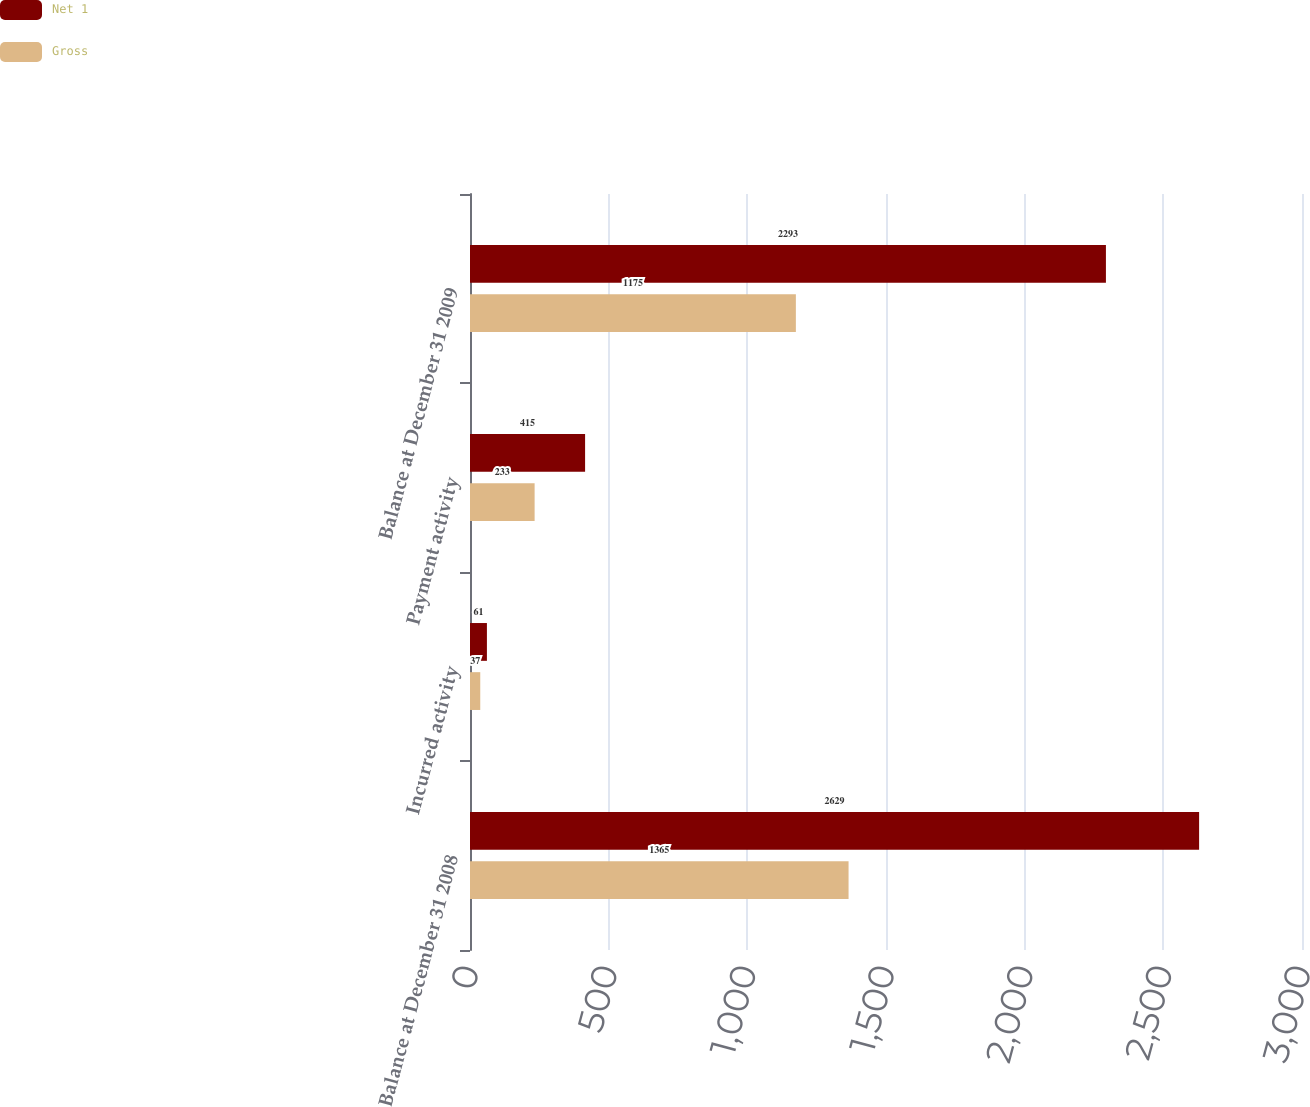Convert chart to OTSL. <chart><loc_0><loc_0><loc_500><loc_500><stacked_bar_chart><ecel><fcel>Balance at December 31 2008<fcel>Incurred activity<fcel>Payment activity<fcel>Balance at December 31 2009<nl><fcel>Net 1<fcel>2629<fcel>61<fcel>415<fcel>2293<nl><fcel>Gross<fcel>1365<fcel>37<fcel>233<fcel>1175<nl></chart> 